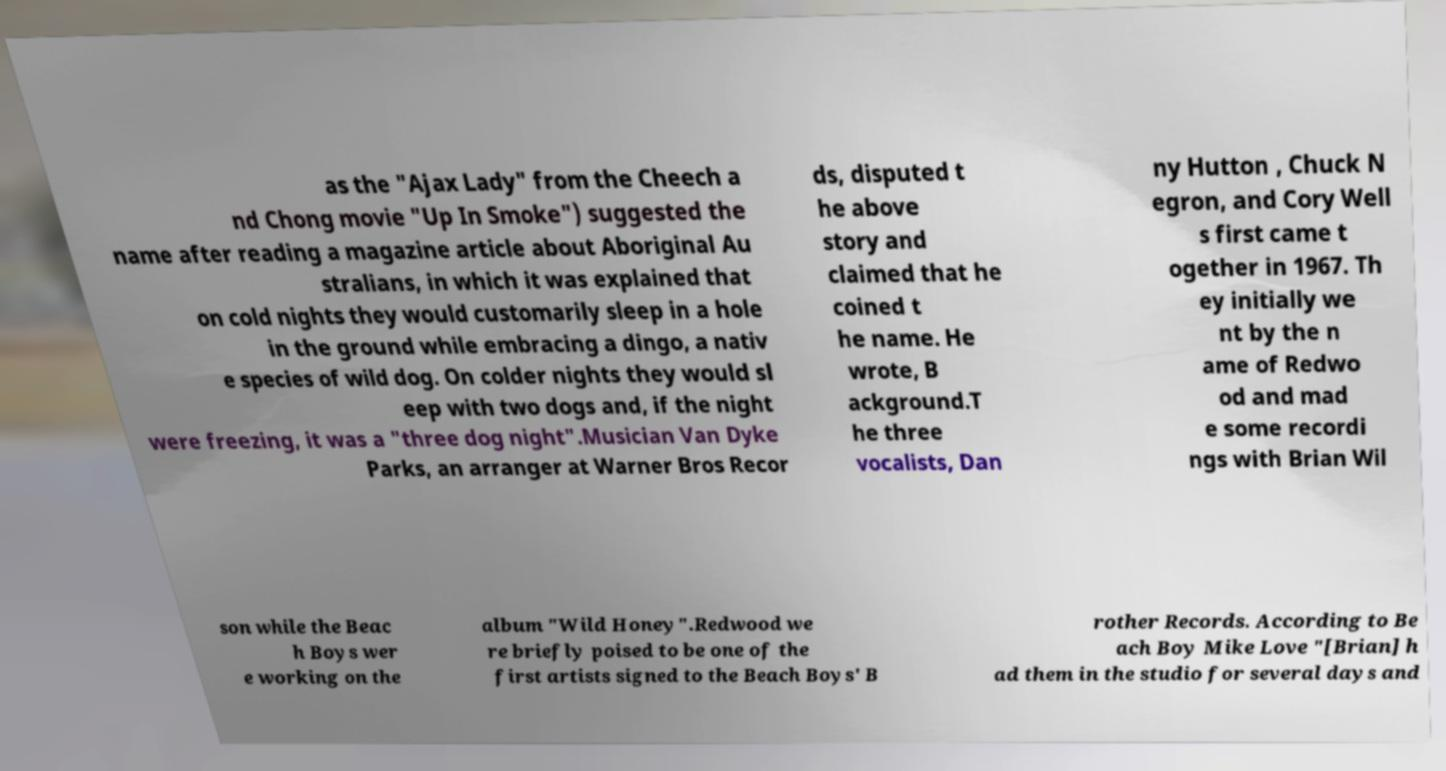For documentation purposes, I need the text within this image transcribed. Could you provide that? as the "Ajax Lady" from the Cheech a nd Chong movie "Up In Smoke") suggested the name after reading a magazine article about Aboriginal Au stralians, in which it was explained that on cold nights they would customarily sleep in a hole in the ground while embracing a dingo, a nativ e species of wild dog. On colder nights they would sl eep with two dogs and, if the night were freezing, it was a "three dog night".Musician Van Dyke Parks, an arranger at Warner Bros Recor ds, disputed t he above story and claimed that he coined t he name. He wrote, B ackground.T he three vocalists, Dan ny Hutton , Chuck N egron, and Cory Well s first came t ogether in 1967. Th ey initially we nt by the n ame of Redwo od and mad e some recordi ngs with Brian Wil son while the Beac h Boys wer e working on the album "Wild Honey".Redwood we re briefly poised to be one of the first artists signed to the Beach Boys' B rother Records. According to Be ach Boy Mike Love "[Brian] h ad them in the studio for several days and 